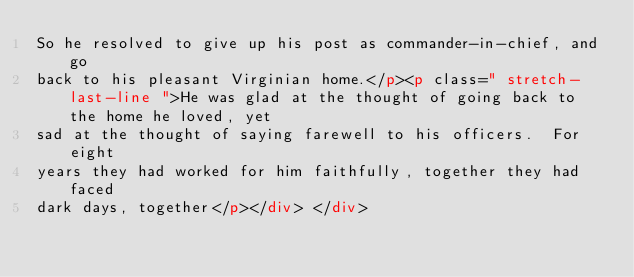<code> <loc_0><loc_0><loc_500><loc_500><_HTML_>So he resolved to give up his post as commander-in-chief, and go
back to his pleasant Virginian home.</p><p class=" stretch-last-line ">He was glad at the thought of going back to the home he loved, yet
sad at the thought of saying farewell to his officers.  For eight
years they had worked for him faithfully, together they had faced
dark days, together</p></div> </div></code> 